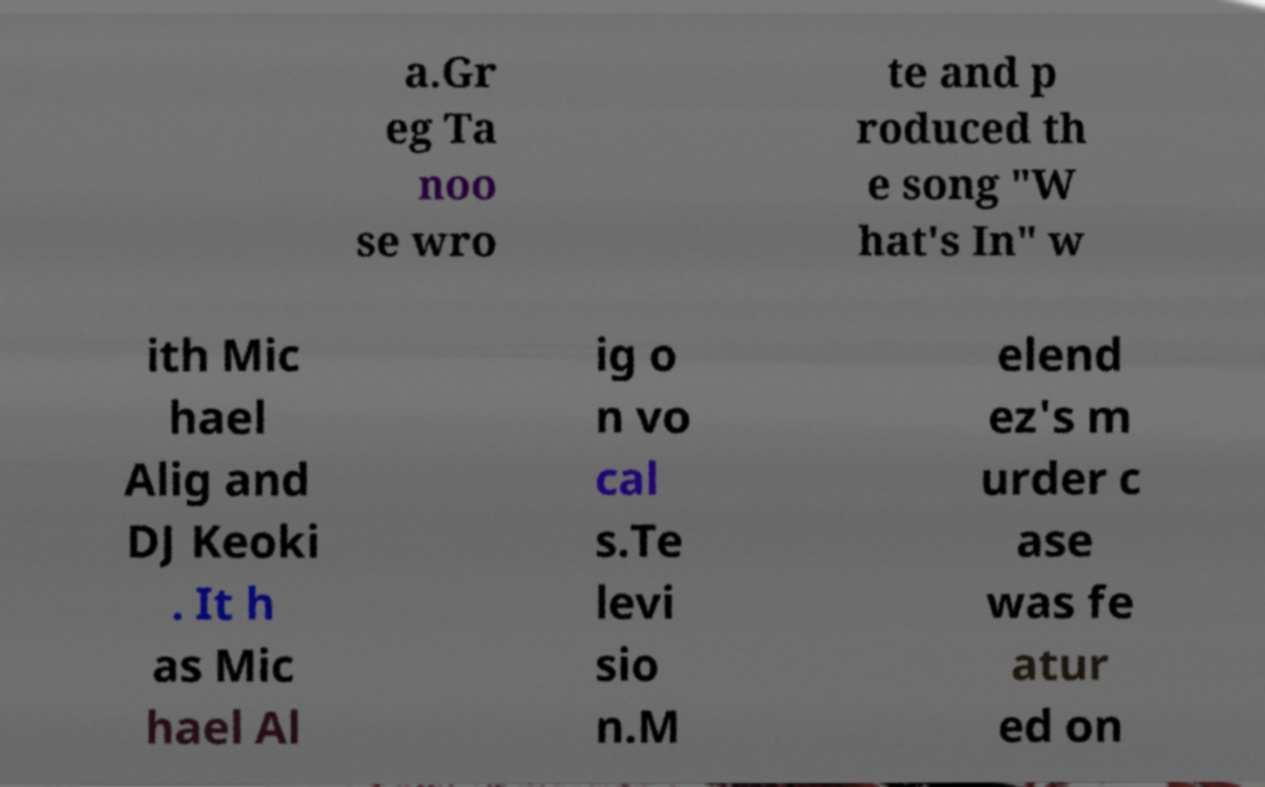Can you read and provide the text displayed in the image?This photo seems to have some interesting text. Can you extract and type it out for me? a.Gr eg Ta noo se wro te and p roduced th e song "W hat's In" w ith Mic hael Alig and DJ Keoki . It h as Mic hael Al ig o n vo cal s.Te levi sio n.M elend ez's m urder c ase was fe atur ed on 